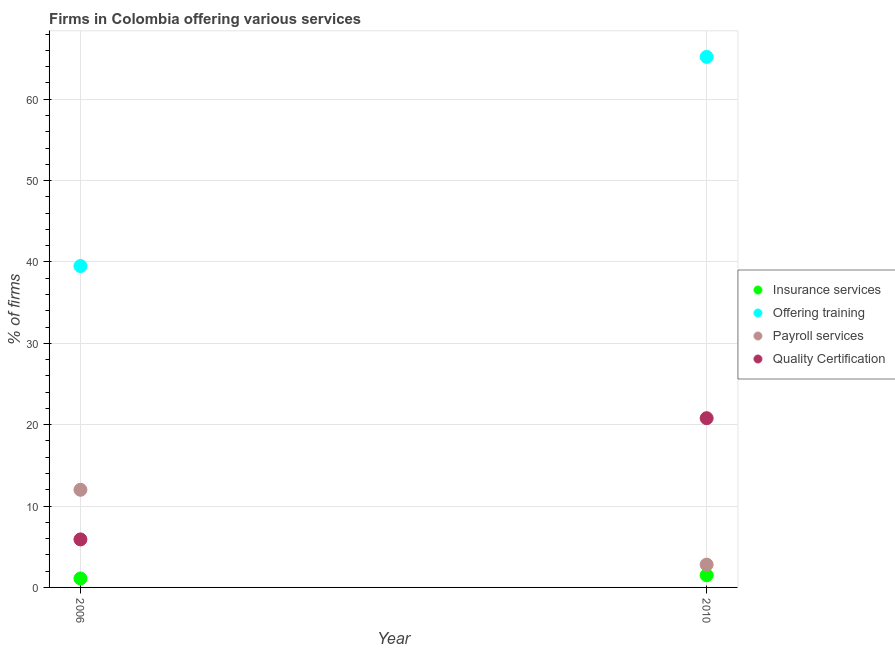How many different coloured dotlines are there?
Offer a terse response. 4. Is the number of dotlines equal to the number of legend labels?
Provide a short and direct response. Yes. Across all years, what is the maximum percentage of firms offering insurance services?
Provide a succinct answer. 1.5. Across all years, what is the minimum percentage of firms offering insurance services?
Provide a short and direct response. 1.1. In which year was the percentage of firms offering payroll services minimum?
Ensure brevity in your answer.  2010. What is the total percentage of firms offering quality certification in the graph?
Make the answer very short. 26.7. What is the difference between the percentage of firms offering insurance services in 2006 and that in 2010?
Make the answer very short. -0.4. What is the difference between the percentage of firms offering quality certification in 2010 and the percentage of firms offering payroll services in 2006?
Make the answer very short. 8.8. What is the average percentage of firms offering training per year?
Make the answer very short. 52.35. In the year 2006, what is the difference between the percentage of firms offering insurance services and percentage of firms offering training?
Keep it short and to the point. -38.4. What is the ratio of the percentage of firms offering training in 2006 to that in 2010?
Your answer should be very brief. 0.61. Is the percentage of firms offering training in 2006 less than that in 2010?
Provide a succinct answer. Yes. In how many years, is the percentage of firms offering payroll services greater than the average percentage of firms offering payroll services taken over all years?
Offer a very short reply. 1. Is it the case that in every year, the sum of the percentage of firms offering insurance services and percentage of firms offering training is greater than the percentage of firms offering payroll services?
Make the answer very short. Yes. Does the percentage of firms offering insurance services monotonically increase over the years?
Provide a succinct answer. Yes. Is the percentage of firms offering quality certification strictly less than the percentage of firms offering insurance services over the years?
Your response must be concise. No. What is the difference between two consecutive major ticks on the Y-axis?
Ensure brevity in your answer.  10. Does the graph contain any zero values?
Make the answer very short. No. Does the graph contain grids?
Your response must be concise. Yes. How are the legend labels stacked?
Make the answer very short. Vertical. What is the title of the graph?
Provide a succinct answer. Firms in Colombia offering various services . What is the label or title of the X-axis?
Your answer should be compact. Year. What is the label or title of the Y-axis?
Your response must be concise. % of firms. What is the % of firms of Offering training in 2006?
Make the answer very short. 39.5. What is the % of firms of Insurance services in 2010?
Make the answer very short. 1.5. What is the % of firms of Offering training in 2010?
Your answer should be compact. 65.2. What is the % of firms in Payroll services in 2010?
Provide a short and direct response. 2.8. What is the % of firms of Quality Certification in 2010?
Make the answer very short. 20.8. Across all years, what is the maximum % of firms in Offering training?
Give a very brief answer. 65.2. Across all years, what is the maximum % of firms in Quality Certification?
Your response must be concise. 20.8. Across all years, what is the minimum % of firms in Offering training?
Provide a succinct answer. 39.5. What is the total % of firms of Insurance services in the graph?
Provide a succinct answer. 2.6. What is the total % of firms in Offering training in the graph?
Keep it short and to the point. 104.7. What is the total % of firms in Payroll services in the graph?
Provide a succinct answer. 14.8. What is the total % of firms of Quality Certification in the graph?
Ensure brevity in your answer.  26.7. What is the difference between the % of firms of Insurance services in 2006 and that in 2010?
Keep it short and to the point. -0.4. What is the difference between the % of firms of Offering training in 2006 and that in 2010?
Offer a very short reply. -25.7. What is the difference between the % of firms in Quality Certification in 2006 and that in 2010?
Give a very brief answer. -14.9. What is the difference between the % of firms in Insurance services in 2006 and the % of firms in Offering training in 2010?
Make the answer very short. -64.1. What is the difference between the % of firms in Insurance services in 2006 and the % of firms in Quality Certification in 2010?
Provide a succinct answer. -19.7. What is the difference between the % of firms in Offering training in 2006 and the % of firms in Payroll services in 2010?
Give a very brief answer. 36.7. What is the difference between the % of firms of Payroll services in 2006 and the % of firms of Quality Certification in 2010?
Keep it short and to the point. -8.8. What is the average % of firms in Offering training per year?
Make the answer very short. 52.35. What is the average % of firms in Payroll services per year?
Your answer should be compact. 7.4. What is the average % of firms of Quality Certification per year?
Give a very brief answer. 13.35. In the year 2006, what is the difference between the % of firms in Insurance services and % of firms in Offering training?
Offer a terse response. -38.4. In the year 2006, what is the difference between the % of firms of Insurance services and % of firms of Quality Certification?
Your response must be concise. -4.8. In the year 2006, what is the difference between the % of firms in Offering training and % of firms in Quality Certification?
Your answer should be very brief. 33.6. In the year 2010, what is the difference between the % of firms of Insurance services and % of firms of Offering training?
Keep it short and to the point. -63.7. In the year 2010, what is the difference between the % of firms in Insurance services and % of firms in Quality Certification?
Your response must be concise. -19.3. In the year 2010, what is the difference between the % of firms in Offering training and % of firms in Payroll services?
Your answer should be very brief. 62.4. In the year 2010, what is the difference between the % of firms of Offering training and % of firms of Quality Certification?
Offer a terse response. 44.4. In the year 2010, what is the difference between the % of firms of Payroll services and % of firms of Quality Certification?
Keep it short and to the point. -18. What is the ratio of the % of firms in Insurance services in 2006 to that in 2010?
Your response must be concise. 0.73. What is the ratio of the % of firms in Offering training in 2006 to that in 2010?
Ensure brevity in your answer.  0.61. What is the ratio of the % of firms of Payroll services in 2006 to that in 2010?
Give a very brief answer. 4.29. What is the ratio of the % of firms in Quality Certification in 2006 to that in 2010?
Keep it short and to the point. 0.28. What is the difference between the highest and the second highest % of firms of Offering training?
Ensure brevity in your answer.  25.7. What is the difference between the highest and the second highest % of firms of Payroll services?
Keep it short and to the point. 9.2. What is the difference between the highest and the second highest % of firms in Quality Certification?
Keep it short and to the point. 14.9. What is the difference between the highest and the lowest % of firms in Insurance services?
Make the answer very short. 0.4. What is the difference between the highest and the lowest % of firms in Offering training?
Your response must be concise. 25.7. What is the difference between the highest and the lowest % of firms of Payroll services?
Give a very brief answer. 9.2. 